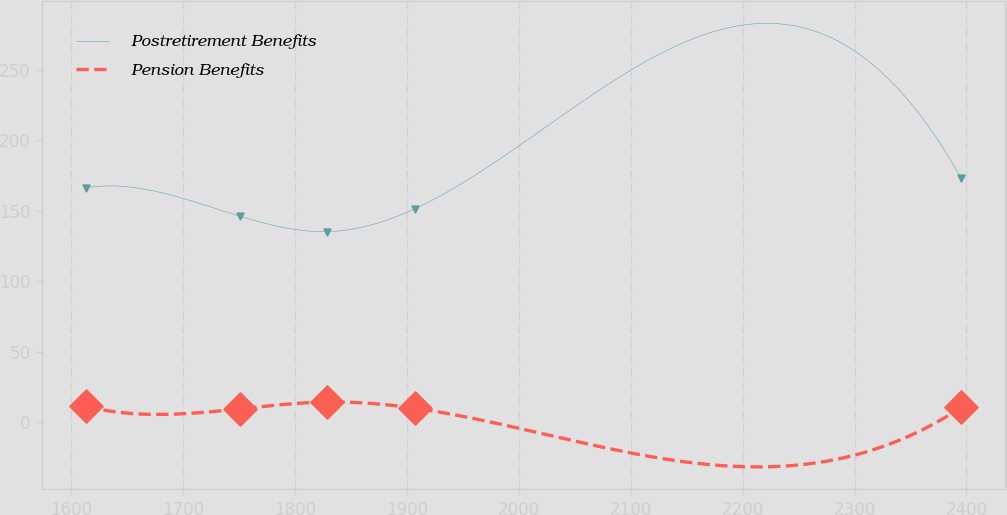<chart> <loc_0><loc_0><loc_500><loc_500><line_chart><ecel><fcel>Postretirement Benefits<fcel>Pension Benefits<nl><fcel>1613.27<fcel>166.42<fcel>11.06<nl><fcel>1750.47<fcel>146.24<fcel>9.3<nl><fcel>1828.67<fcel>135.22<fcel>14.15<nl><fcel>1906.87<fcel>151.42<fcel>9.81<nl><fcel>2395.29<fcel>173.17<fcel>10.29<nl></chart> 